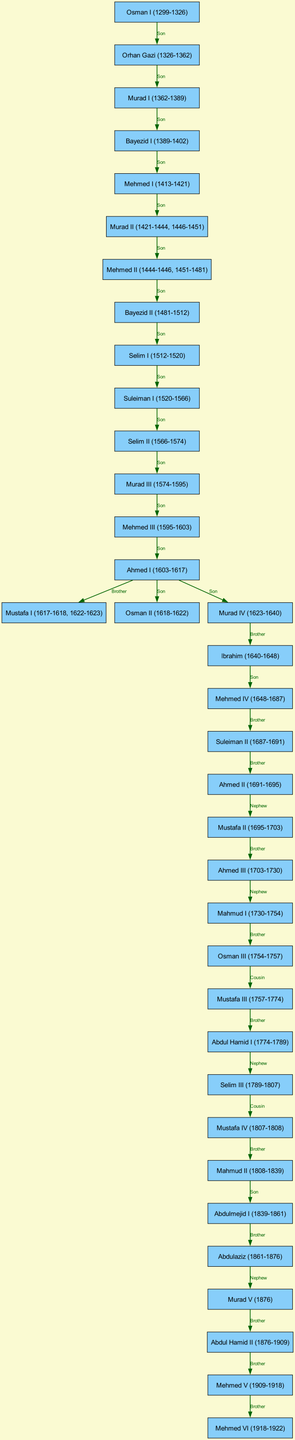What is the time period of Osman I? Osman I reigned from 1299 to 1326, which is explicitly stated in the node label. This date range is directly presented in the diagram.
Answer: 1299-1326 Who is the son of Murad I? The diagram indicates a direct relationship, showing that Murad I (1362-1389) has a son, Bayezid I (1389-1402). This connection is marked on the edge between these two nodes.
Answer: Bayezid I How many total sultans are present in the diagram? Counting each node in the diagram gives a total of 36 distinct sultans, as each signifies a unique reign in the lineage of the Ottoman Empire.
Answer: 36 Which sultan is the brother of Ahmed I? The relationship diagram shows that Ahmed I (1603-1617) has a brother named Mustafa I (1617-1618, 1622-1623). This connection is labeled appropriately between the two nodes.
Answer: Mustafa I What is the relationship between Mehmed V and Mehmed VI? The diagram indicates a direct relationship where Mehmed V (1909-1918) is the brother of Mehmed VI (1918-1922), proved by the edge connecting these nodes labeled "Brother."
Answer: Brother Which sultans are directly related as nephew and uncle? To identify the nephew relations, we can see that Abdul Hamid I (1774-1789) is the uncle to Selim III (1789-1807), based on the line connecting them labeled "Nephew." This type of family relationship is highlighted within the diagram's structure.
Answer: Abdul Hamid I and Selim III Who was the last sultan of the Ottoman Empire? Mehmed VI (1918-1922) is represented as the last sultan at the end of the lineage and is clearly indicated at the bottom of the diagram.
Answer: Mehmed VI How many edges connect the reigns of the Ottoman sultans? By counting all the directed edges in the diagram that represent parent-child relations, a total of 35 edges can be determined, which illustrates the connections among the sultans.
Answer: 35 What indicates the relationship between Ahmed II and Mustafa II? The diagram shows that Ahmed II (1691-1695) is the uncle to Mustafa II (1695-1703), specified by the connection labeled "Nephew," demonstrating their family relationship.
Answer: Uncle and Nephew 